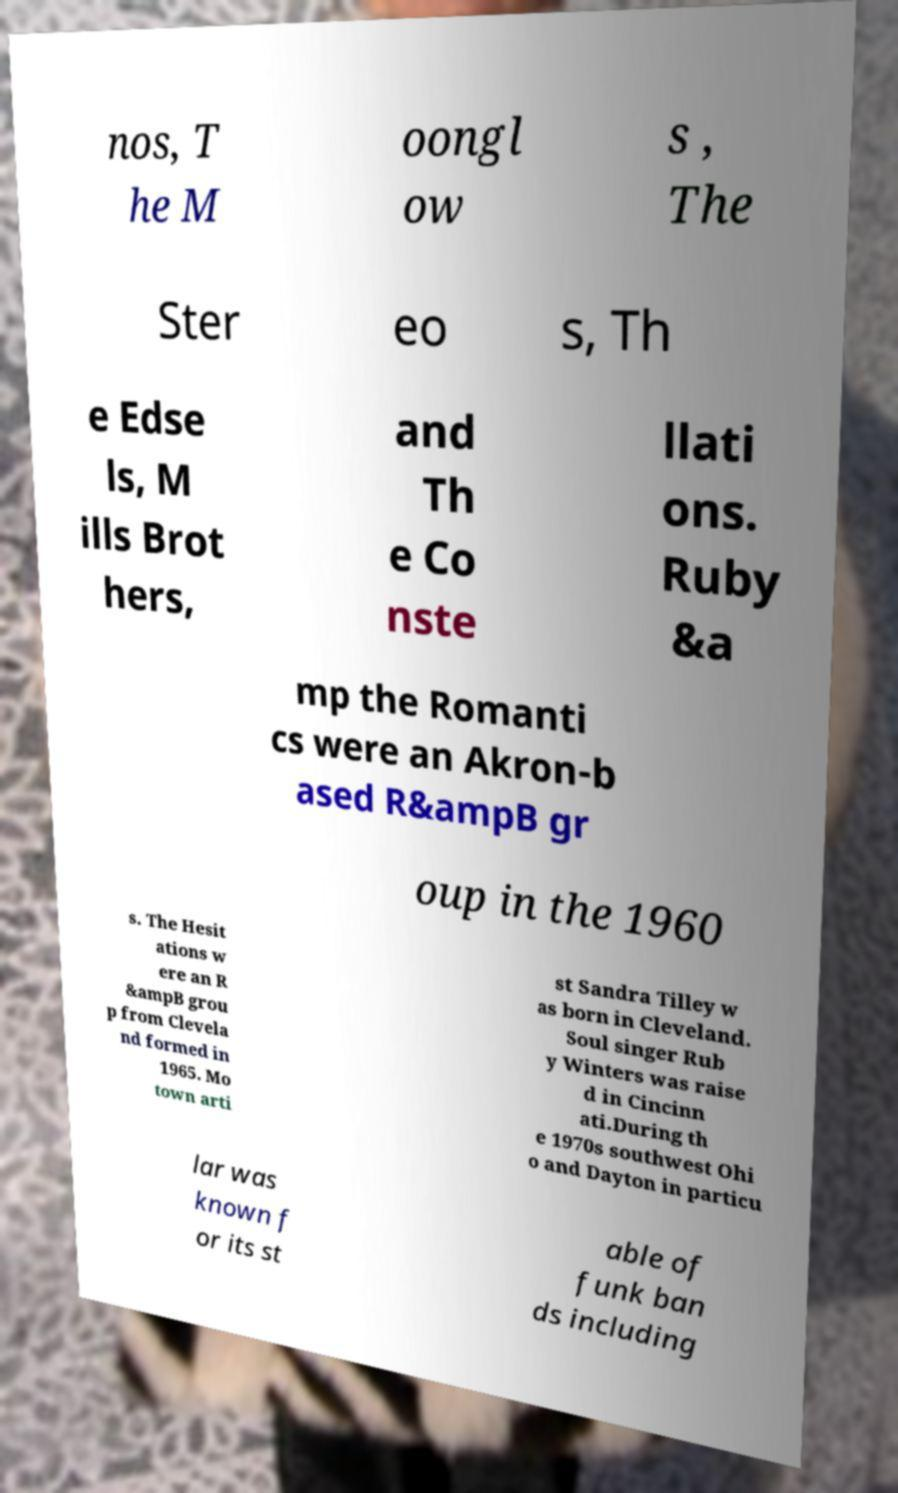There's text embedded in this image that I need extracted. Can you transcribe it verbatim? nos, T he M oongl ow s , The Ster eo s, Th e Edse ls, M ills Brot hers, and Th e Co nste llati ons. Ruby &a mp the Romanti cs were an Akron-b ased R&ampB gr oup in the 1960 s. The Hesit ations w ere an R &ampB grou p from Clevela nd formed in 1965. Mo town arti st Sandra Tilley w as born in Cleveland. Soul singer Rub y Winters was raise d in Cincinn ati.During th e 1970s southwest Ohi o and Dayton in particu lar was known f or its st able of funk ban ds including 